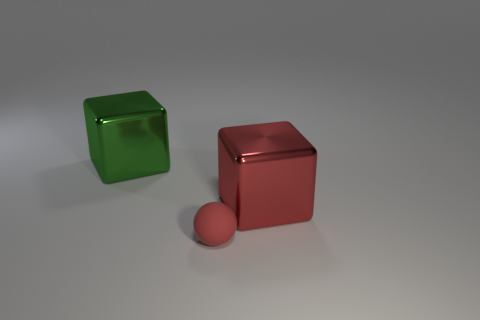Is there any other thing that is the same size as the red shiny thing? Yes, the red sphere appears to be approximately the same size as the edge length of the red cube. 